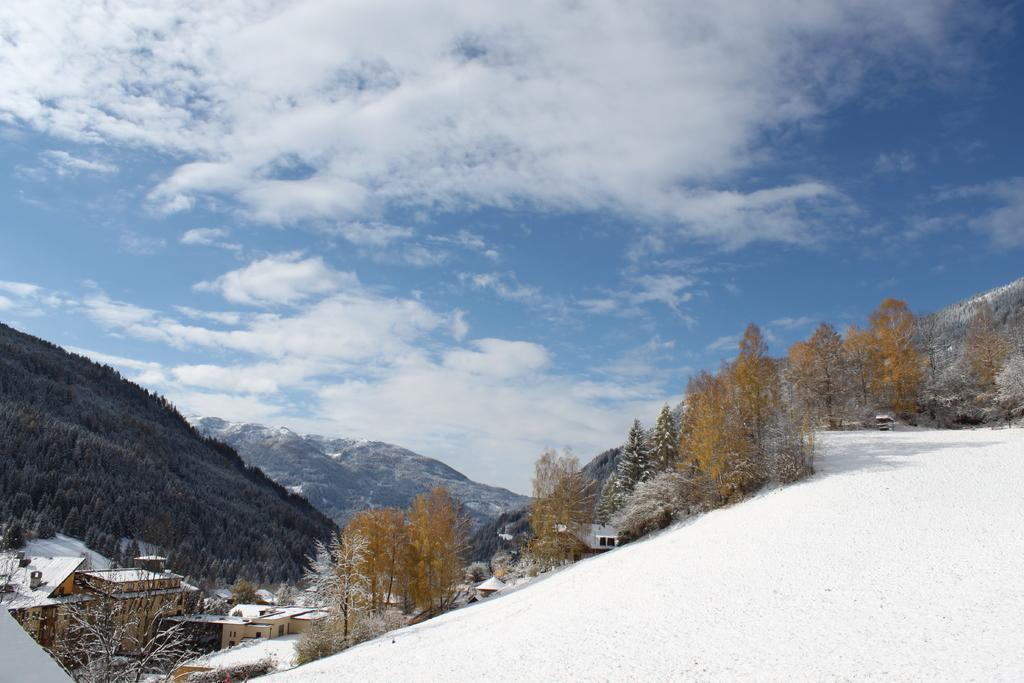Describe this image in one or two sentences. In the image in the center there are trees, there are buildings and in the background there are mountains and the sky is cloudy. 